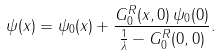Convert formula to latex. <formula><loc_0><loc_0><loc_500><loc_500>\psi ( { x } ) = \psi _ { 0 } ( { x } ) + \frac { G _ { 0 } ^ { R } ( { x } , { 0 } ) \, \psi _ { 0 } ( { 0 } ) } { \frac { 1 } { \lambda } - G _ { 0 } ^ { R } ( { 0 } , { 0 } ) } .</formula> 